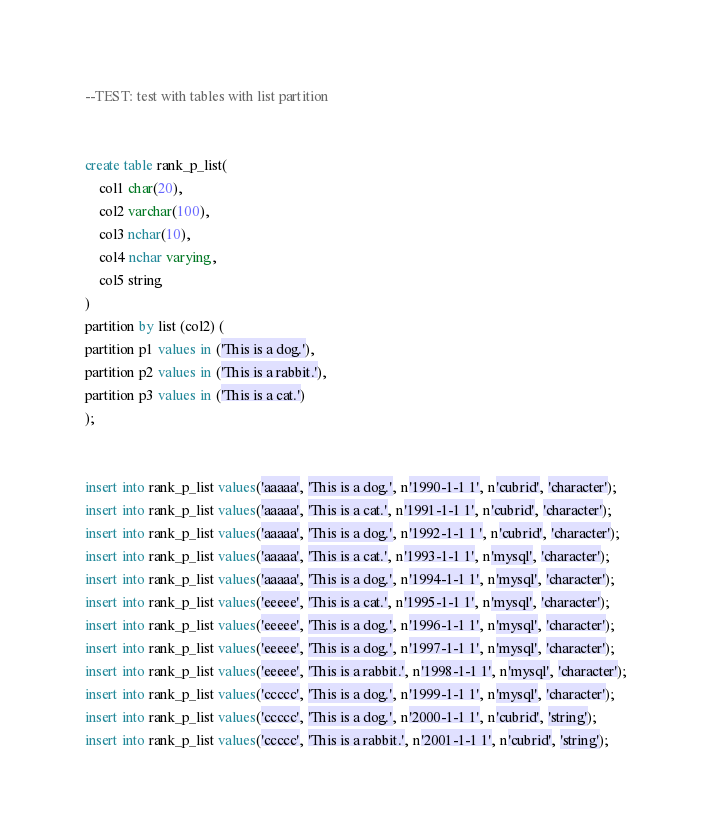Convert code to text. <code><loc_0><loc_0><loc_500><loc_500><_SQL_>--TEST: test with tables with list partition


create table rank_p_list(
	col1 char(20),
	col2 varchar(100), 
	col3 nchar(10),
	col4 nchar varying,
	col5 string
)
partition by list (col2) (
partition p1 values in ('This is a dog.'),
partition p2 values in ('This is a rabbit.'),
partition p3 values in ('This is a cat.')
);


insert into rank_p_list values('aaaaa', 'This is a dog.', n'1990-1-1 1', n'cubrid', 'character');
insert into rank_p_list values('aaaaa', 'This is a cat.', n'1991-1-1 1', n'cubrid', 'character');
insert into rank_p_list values('aaaaa', 'This is a dog.', n'1992-1-1 1 ', n'cubrid', 'character');
insert into rank_p_list values('aaaaa', 'This is a cat.', n'1993-1-1 1', n'mysql', 'character');
insert into rank_p_list values('aaaaa', 'This is a dog.', n'1994-1-1 1', n'mysql', 'character');
insert into rank_p_list values('eeeee', 'This is a cat.', n'1995-1-1 1', n'mysql', 'character');
insert into rank_p_list values('eeeee', 'This is a dog.', n'1996-1-1 1', n'mysql', 'character');
insert into rank_p_list values('eeeee', 'This is a dog.', n'1997-1-1 1', n'mysql', 'character');
insert into rank_p_list values('eeeee', 'This is a rabbit.', n'1998-1-1 1', n'mysql', 'character');
insert into rank_p_list values('ccccc', 'This is a dog.', n'1999-1-1 1', n'mysql', 'character');
insert into rank_p_list values('ccccc', 'This is a dog.', n'2000-1-1 1', n'cubrid', 'string');
insert into rank_p_list values('ccccc', 'This is a rabbit.', n'2001-1-1 1', n'cubrid', 'string');</code> 